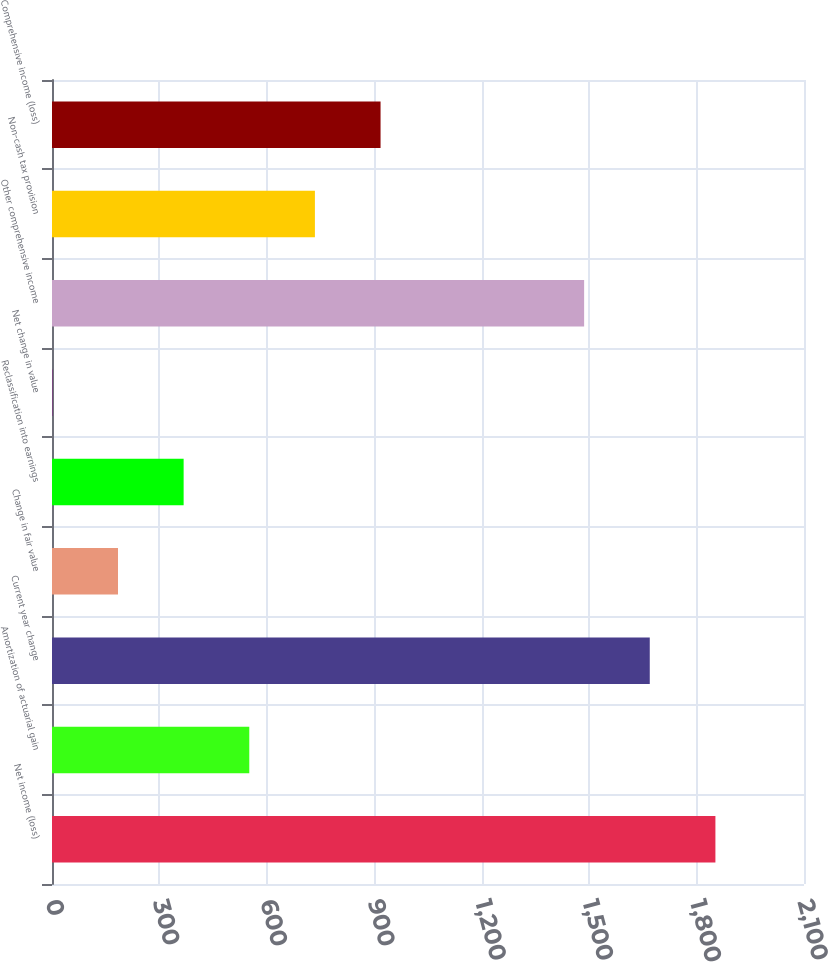Convert chart. <chart><loc_0><loc_0><loc_500><loc_500><bar_chart><fcel>Net income (loss)<fcel>Amortization of actuarial gain<fcel>Current year change<fcel>Change in fair value<fcel>Reclassification into earnings<fcel>Net change in value<fcel>Other comprehensive income<fcel>Non-cash tax provision<fcel>Comprehensive income (loss)<nl><fcel>1852.6<fcel>550.9<fcel>1669.3<fcel>184.3<fcel>367.6<fcel>1<fcel>1486<fcel>734.2<fcel>917.5<nl></chart> 